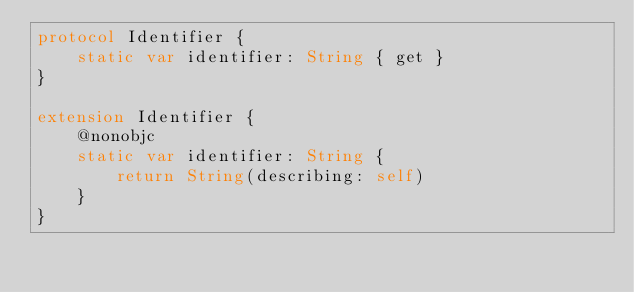Convert code to text. <code><loc_0><loc_0><loc_500><loc_500><_Swift_>protocol Identifier {
    static var identifier: String { get }
}

extension Identifier {
    @nonobjc
    static var identifier: String {
        return String(describing: self)
    }
}
</code> 